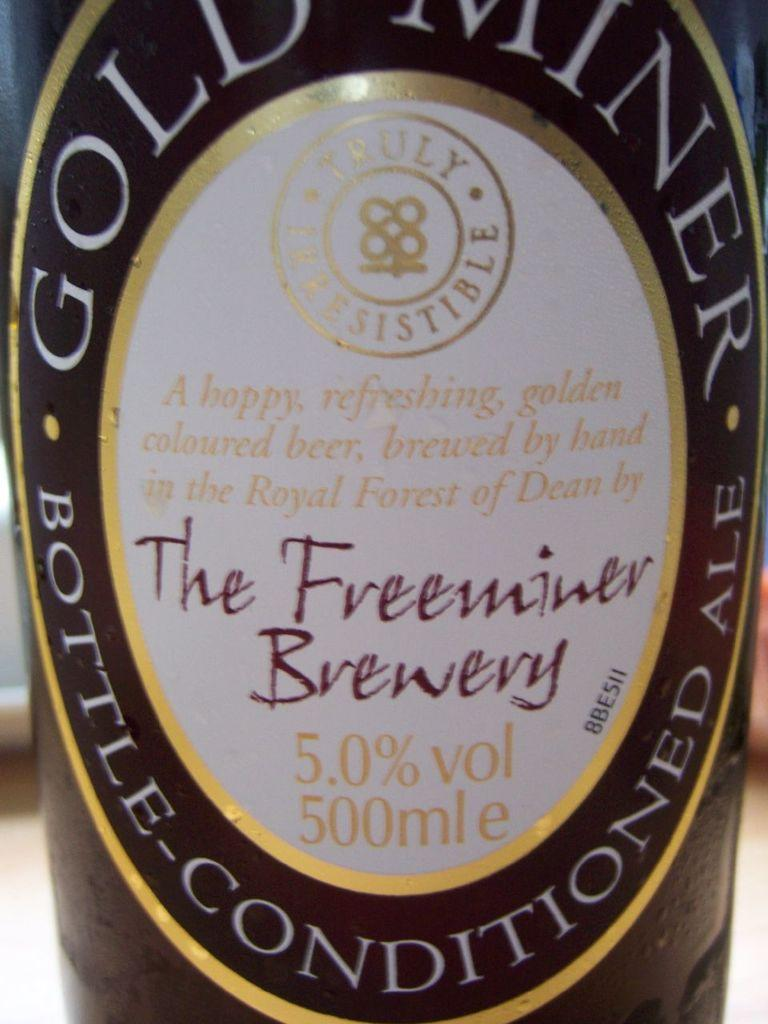<image>
Provide a brief description of the given image. 500 ml Bottle of Bet from Gold Miner Brand from The Freeminer Brewery 